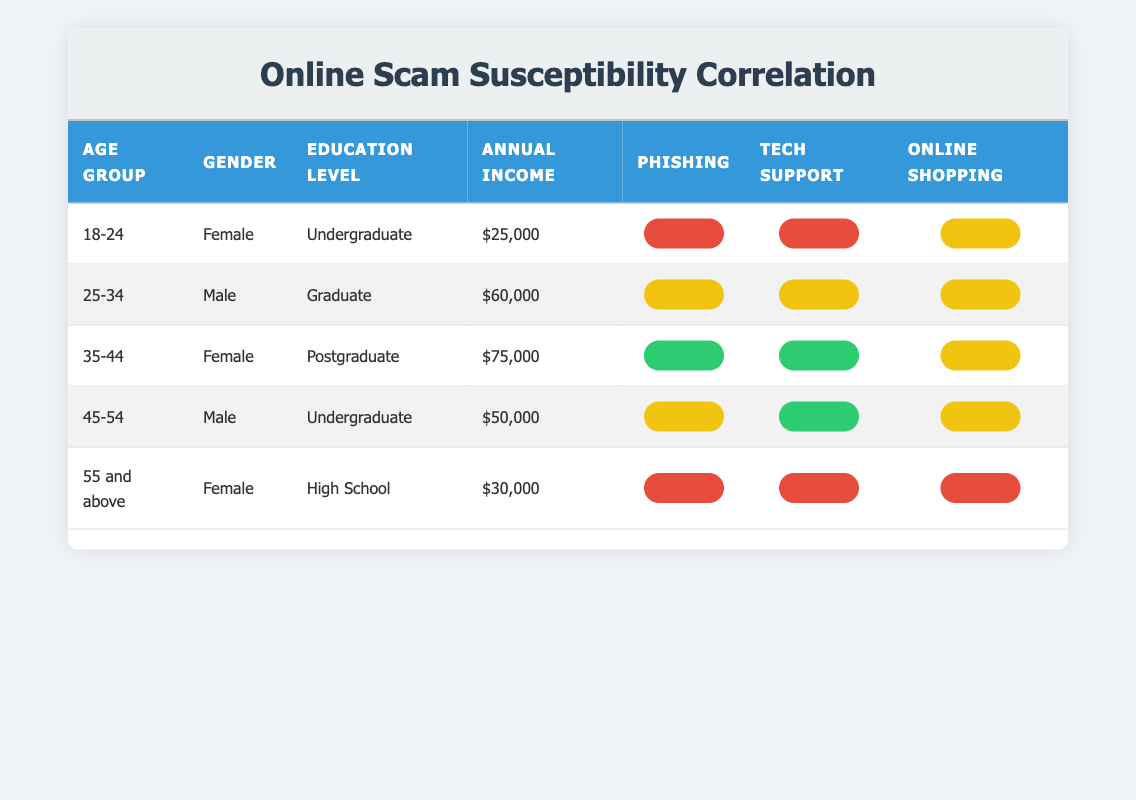What is the scam susceptibility to phishing for individuals aged 45-54? The table shows that individuals aged 45-54 have a phishing scam susceptibility of 0.45.
Answer: 0.45 What is the highest annual income among the groups listed? The highest annual income listed is $75,000, corresponding to the age group 35-44 with a postgraduate education level.
Answer: $75,000 What percentage of individuals aged 18-24 are susceptible to online shopping scams? Individuals aged 18-24 have a susceptibility rate of 0.60 to online shopping scams as per the table.
Answer: 0.60 Is the scam susceptibility to tech support scams higher for females aged 55 and above than for males aged 25-34? Females aged 55 and above have a tech support scam susceptibility of 0.80, while males aged 25-34 have a susceptibility of 0.40. Since 0.80 is greater than 0.40, the statement is true.
Answer: Yes What is the average scam susceptibility to phishing for all age groups? To calculate the average, sum the phishing susceptibility values: 0.65 + 0.55 + 0.30 + 0.45 + 0.75 = 2.70. Now divide by the number of groups (5): 2.70 / 5 = 0.54.
Answer: 0.54 Which age group has the lowest susceptibility to tech support scams? The age group 35-44 has the lowest tech support scam susceptibility of 0.25 according to the table.
Answer: 35-44 How do the scam susceptibility percentages to phishing compare between the gender groups for individuals aged 18-24? For individuals aged 18-24, only females are mentioned with a phishing susceptibility of 0.65; thus no comparison can be made with males in this age group.
Answer: Not applicable Which demographic has the highest susceptibility for online shopping scams? The demographic aged 55 and above has the highest online shopping scam susceptibility at 0.65.
Answer: 55 and above Are both genders equally susceptible to online shopping scams in the 45-54 age group? For the 45-54 age group, males have an online shopping susceptibility of 0.55 and no females are listed in this age category for comparison, thus implying unequal susceptibility.
Answer: No 